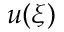<formula> <loc_0><loc_0><loc_500><loc_500>u ( \xi )</formula> 